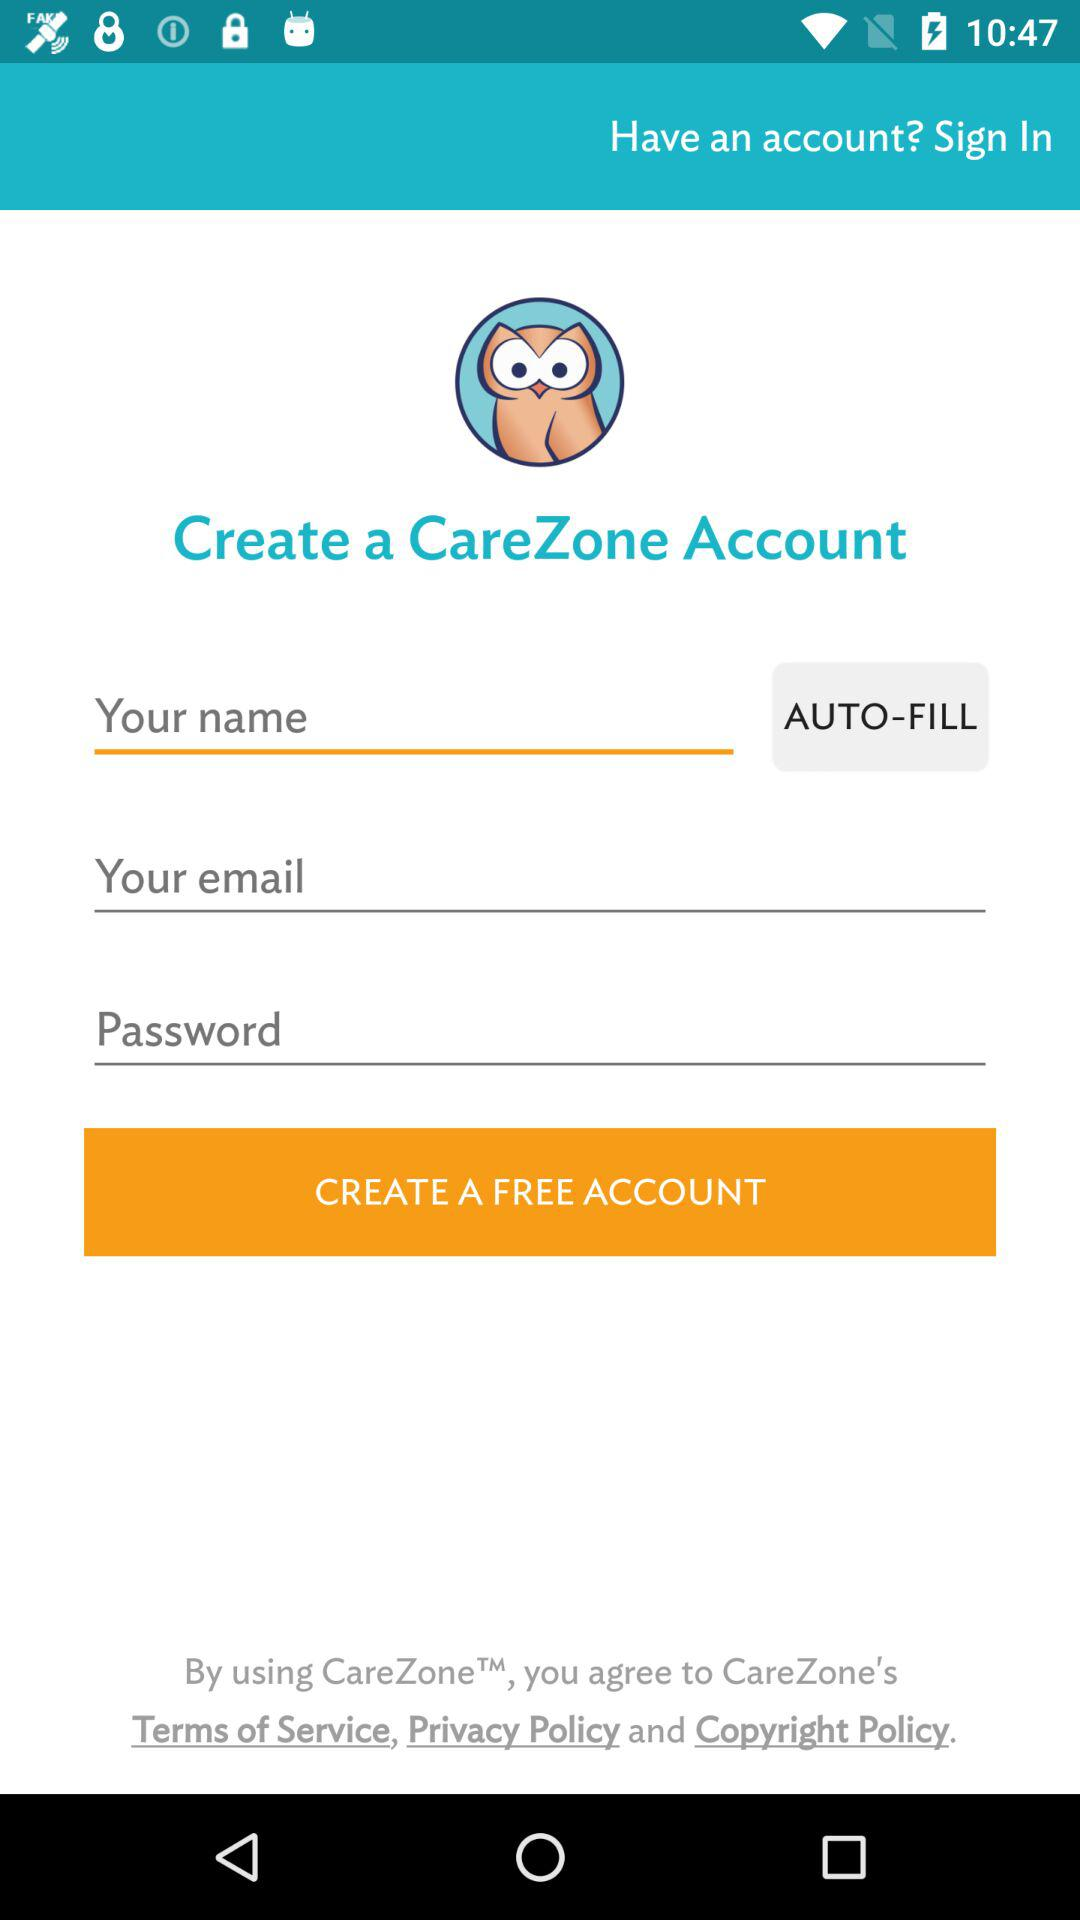How many text inputs are there for creating a CareZone account?
Answer the question using a single word or phrase. 3 